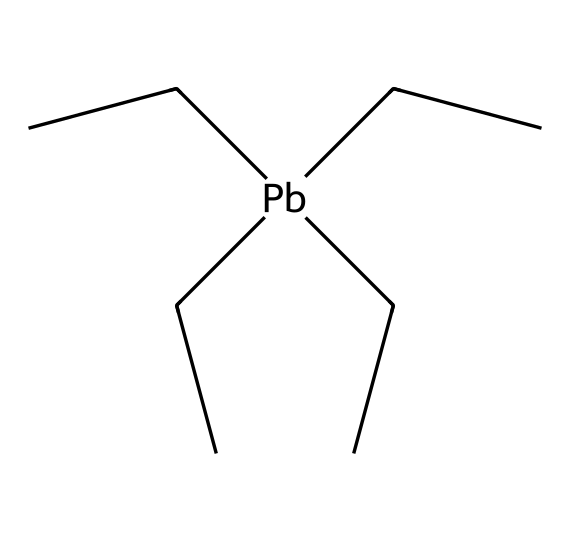What is the central atom in this structure? The central atom is represented by "Pb" in the SMILES notation, which stands for lead.
Answer: lead How many carbon atoms are present in this molecule? By analyzing the structure, we can see that there are five carbon atoms (CC)(CC)(CC)CC, which contribute to the branched alkyl groups.
Answer: five What functional group does this molecule primarily represent? The presence of lead in an alkyl group indicates that this compound is an organolead compound, specifically a type of lead additive.
Answer: organolead How many alkyl groups are attached to the lead atom? The lead atom is bound to four total carbon alkyl groups, indicated by the four branches in the SMILES notation (two from (CC) and two from (CC)(CC)).
Answer: four What is the molecular formula based on the presented structure? The presence of one lead atom and five carbon atoms, along with the hydrogen atoms (implied in the structure), allows us to deduce the molecular formula is C5H12Pb.
Answer: C5H12Pb Which element in this molecule is heavy metal? The "Pb" in the SMILES structure signifies lead, which is classified as a heavy metal.
Answer: lead 